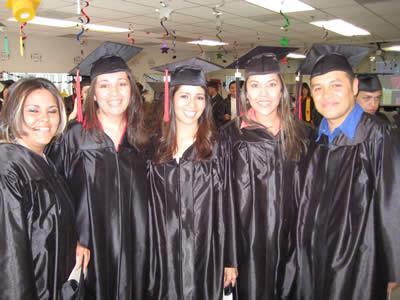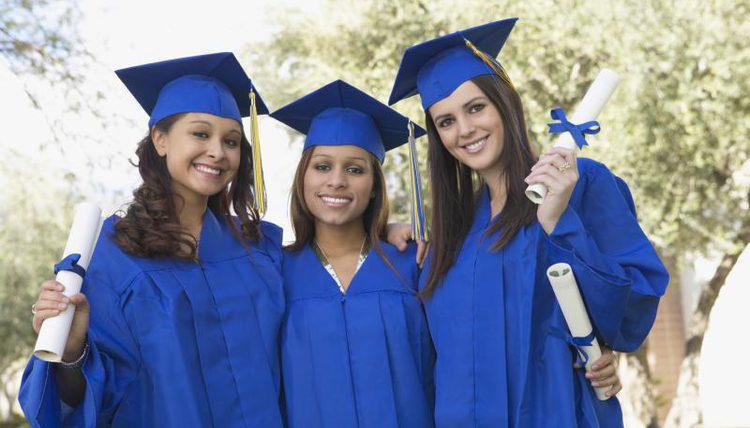The first image is the image on the left, the second image is the image on the right. Given the left and right images, does the statement "One of the images shows only female graduating students." hold true? Answer yes or no. Yes. The first image is the image on the left, the second image is the image on the right. Assess this claim about the two images: "There are 8 graduates in both images.". Correct or not? Answer yes or no. Yes. The first image is the image on the left, the second image is the image on the right. Examine the images to the left and right. Is the description "One image shows a row of all front-facing graduates in black robes, and none wear colored sashes." accurate? Answer yes or no. Yes. The first image is the image on the left, the second image is the image on the right. For the images shown, is this caption "Three people are posing together in graduation attire in one of the images." true? Answer yes or no. Yes. 